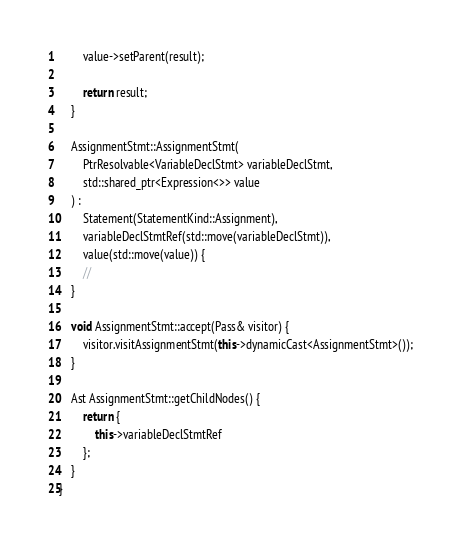Convert code to text. <code><loc_0><loc_0><loc_500><loc_500><_C++_>
        value->setParent(result);

        return result;
    }

    AssignmentStmt::AssignmentStmt(
        PtrResolvable<VariableDeclStmt> variableDeclStmt,
        std::shared_ptr<Expression<>> value
    ) :
        Statement(StatementKind::Assignment),
        variableDeclStmtRef(std::move(variableDeclStmt)),
        value(std::move(value)) {
        //
    }

    void AssignmentStmt::accept(Pass& visitor) {
        visitor.visitAssignmentStmt(this->dynamicCast<AssignmentStmt>());
    }

    Ast AssignmentStmt::getChildNodes() {
        return {
            this->variableDeclStmtRef
        };
    }
}
</code> 